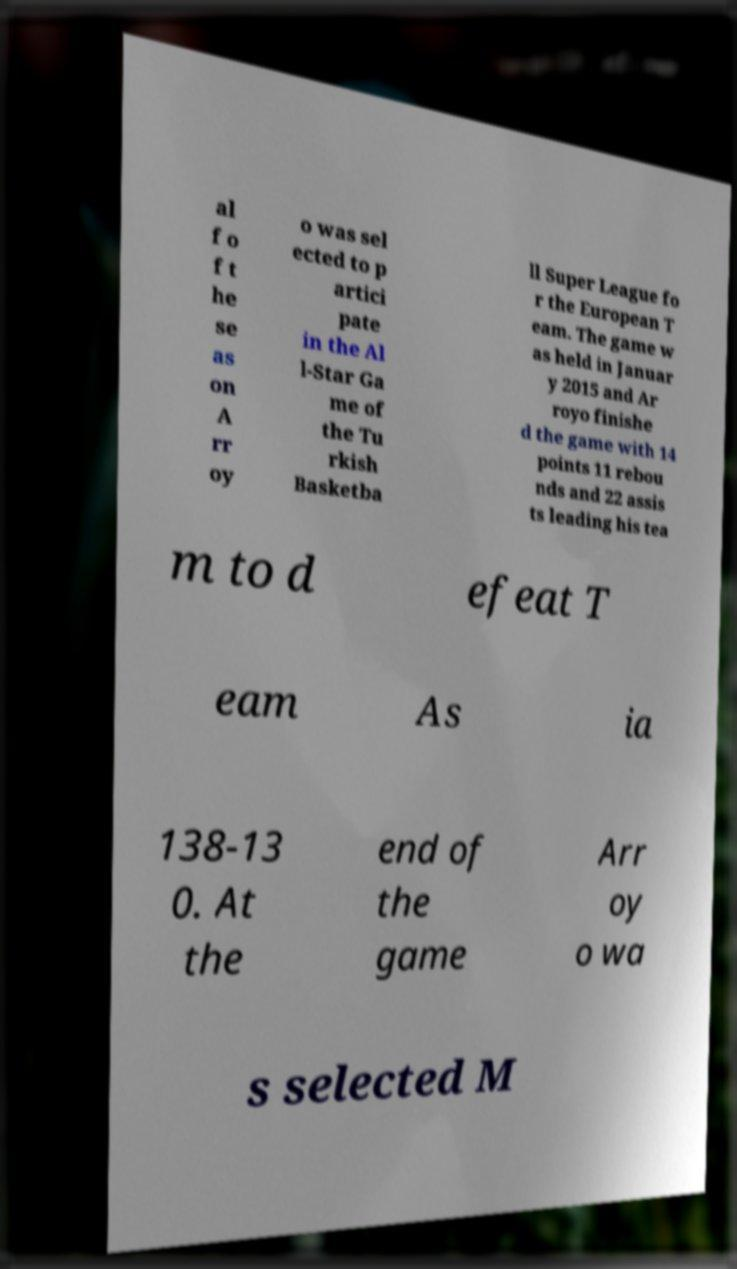There's text embedded in this image that I need extracted. Can you transcribe it verbatim? al f o f t he se as on A rr oy o was sel ected to p artici pate in the Al l-Star Ga me of the Tu rkish Basketba ll Super League fo r the European T eam. The game w as held in Januar y 2015 and Ar royo finishe d the game with 14 points 11 rebou nds and 22 assis ts leading his tea m to d efeat T eam As ia 138-13 0. At the end of the game Arr oy o wa s selected M 